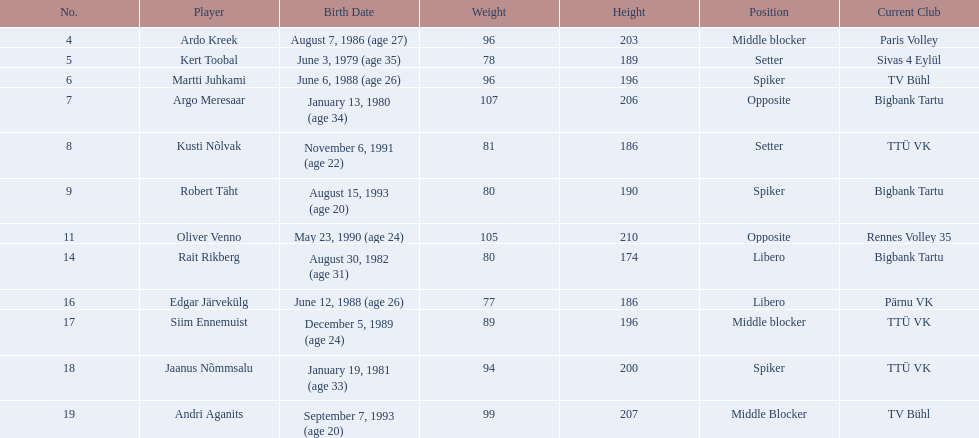Who are all the individuals involved? Ardo Kreek, Kert Toobal, Martti Juhkami, Argo Meresaar, Kusti Nõlvak, Robert Täht, Oliver Venno, Rait Rikberg, Edgar Järvekülg, Siim Ennemuist, Jaanus Nõmmsalu, Andri Aganits. What are their heights? 203, 189, 196, 206, 186, 190, 210, 174, 186, 196, 200, 207. And which individual is the tallest? Oliver Venno. 